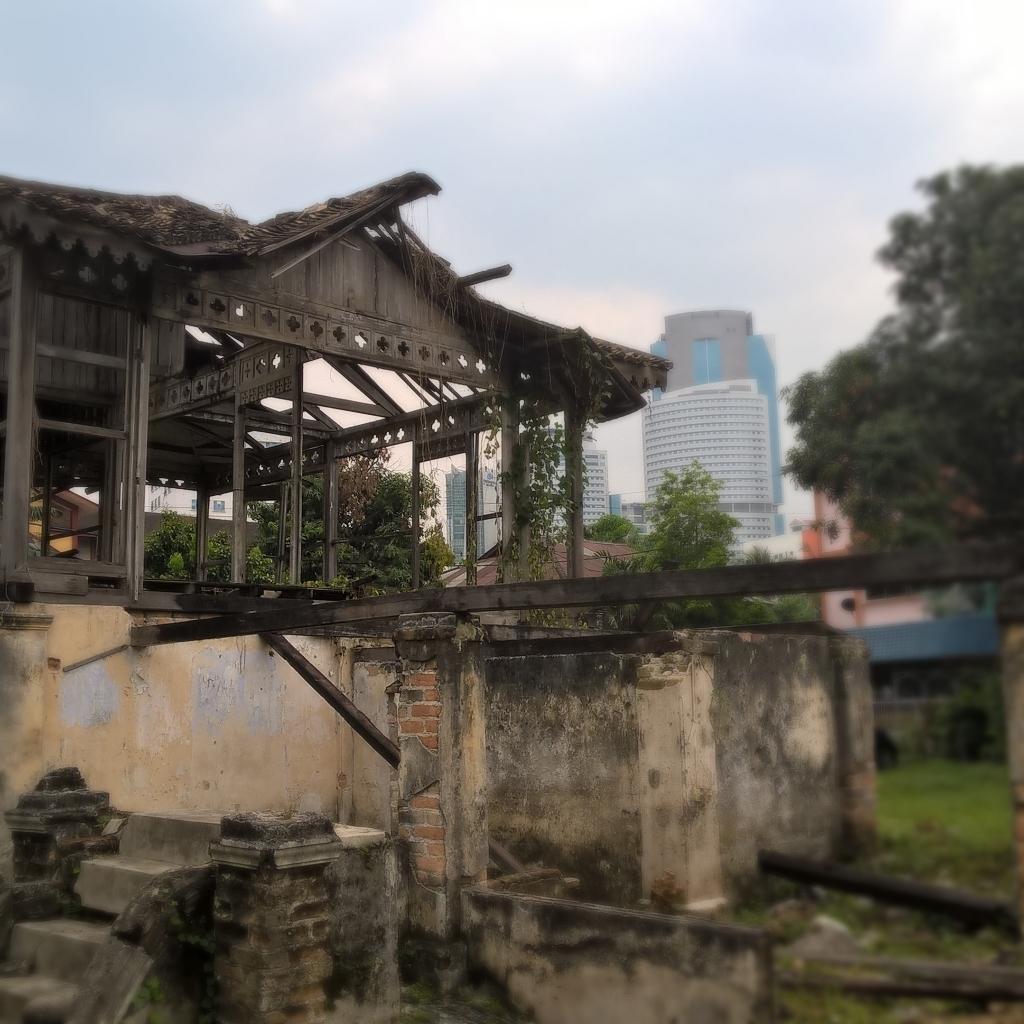Describe this image in one or two sentences. In the image there is a house with wooden poles, roofs and also there are creepers to the poles. At the bottom of the image there is a brick wall and wooden logs. In the background there are trees and buildings. 